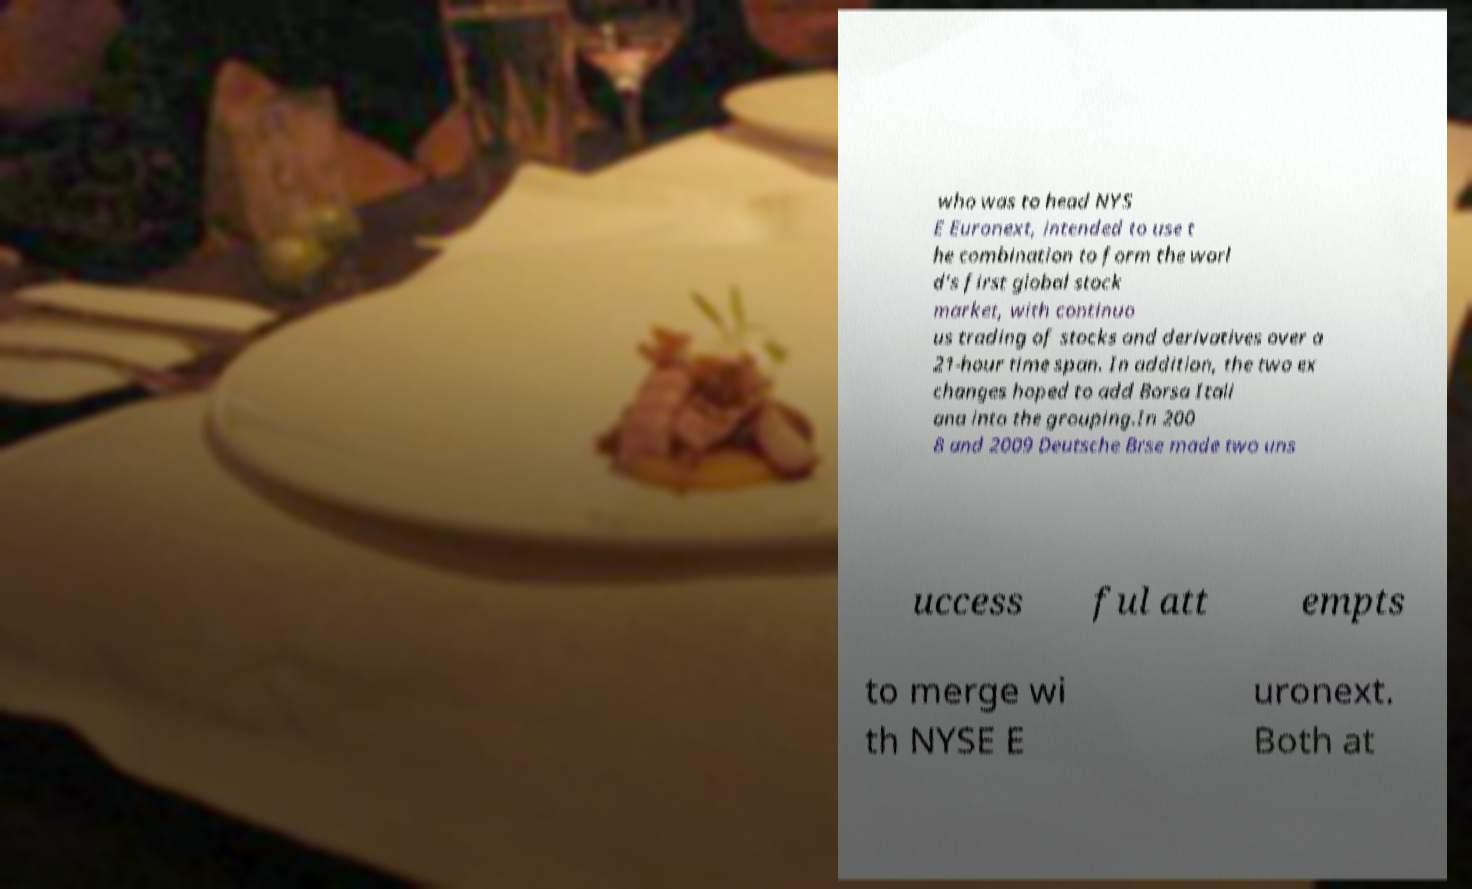Can you accurately transcribe the text from the provided image for me? who was to head NYS E Euronext, intended to use t he combination to form the worl d's first global stock market, with continuo us trading of stocks and derivatives over a 21-hour time span. In addition, the two ex changes hoped to add Borsa Itali ana into the grouping.In 200 8 and 2009 Deutsche Brse made two uns uccess ful att empts to merge wi th NYSE E uronext. Both at 